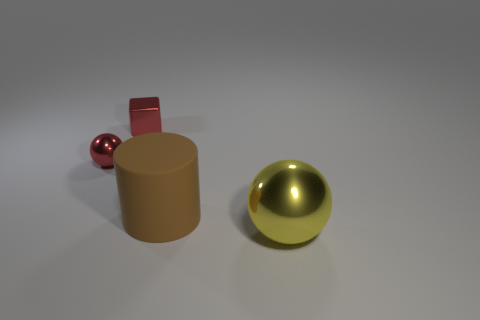Add 4 small gray shiny cylinders. How many objects exist? 8 Subtract all cylinders. How many objects are left? 3 Add 2 red metallic spheres. How many red metallic spheres exist? 3 Subtract 0 green spheres. How many objects are left? 4 Subtract all large brown metallic things. Subtract all big yellow objects. How many objects are left? 3 Add 2 red metal cubes. How many red metal cubes are left? 3 